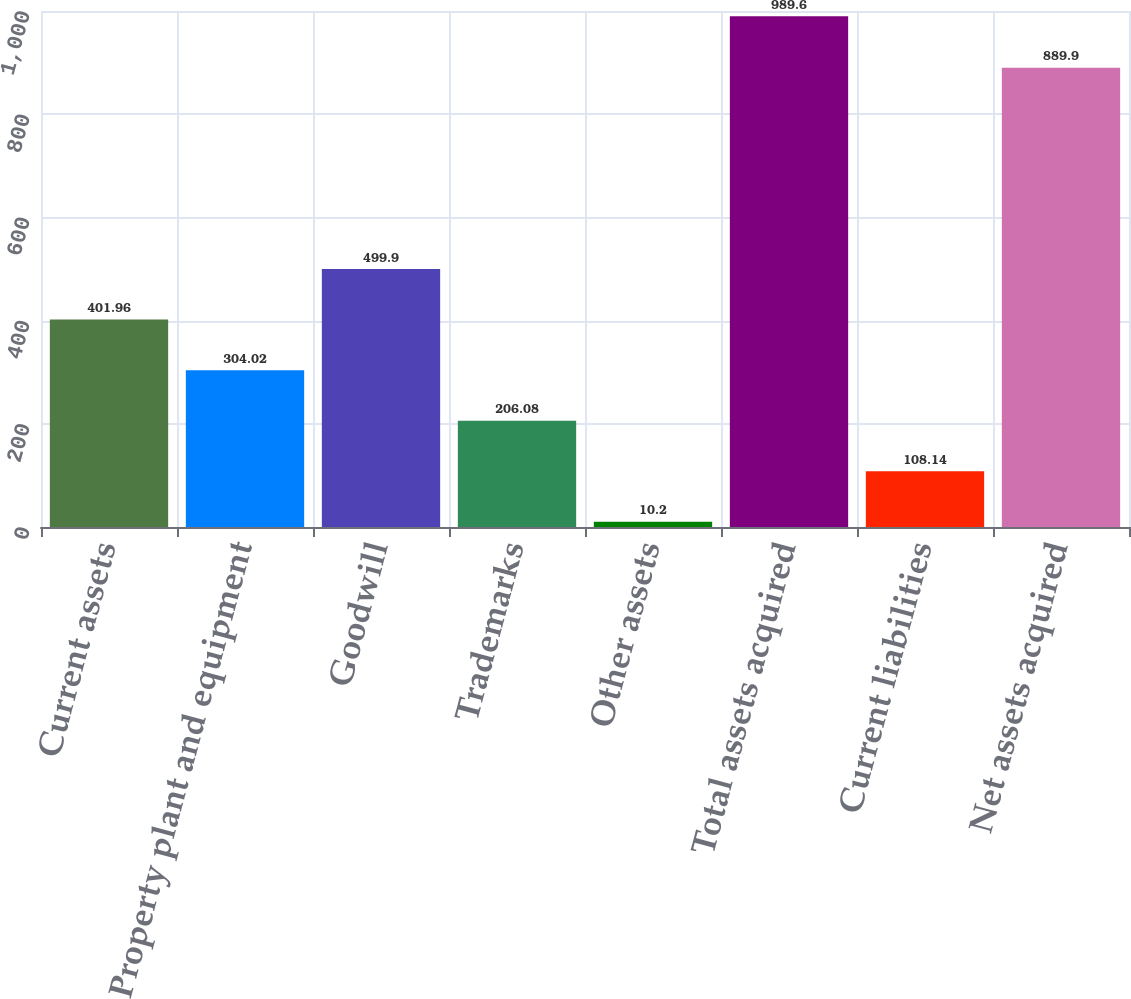Convert chart to OTSL. <chart><loc_0><loc_0><loc_500><loc_500><bar_chart><fcel>Current assets<fcel>Property plant and equipment<fcel>Goodwill<fcel>Trademarks<fcel>Other assets<fcel>Total assets acquired<fcel>Current liabilities<fcel>Net assets acquired<nl><fcel>401.96<fcel>304.02<fcel>499.9<fcel>206.08<fcel>10.2<fcel>989.6<fcel>108.14<fcel>889.9<nl></chart> 